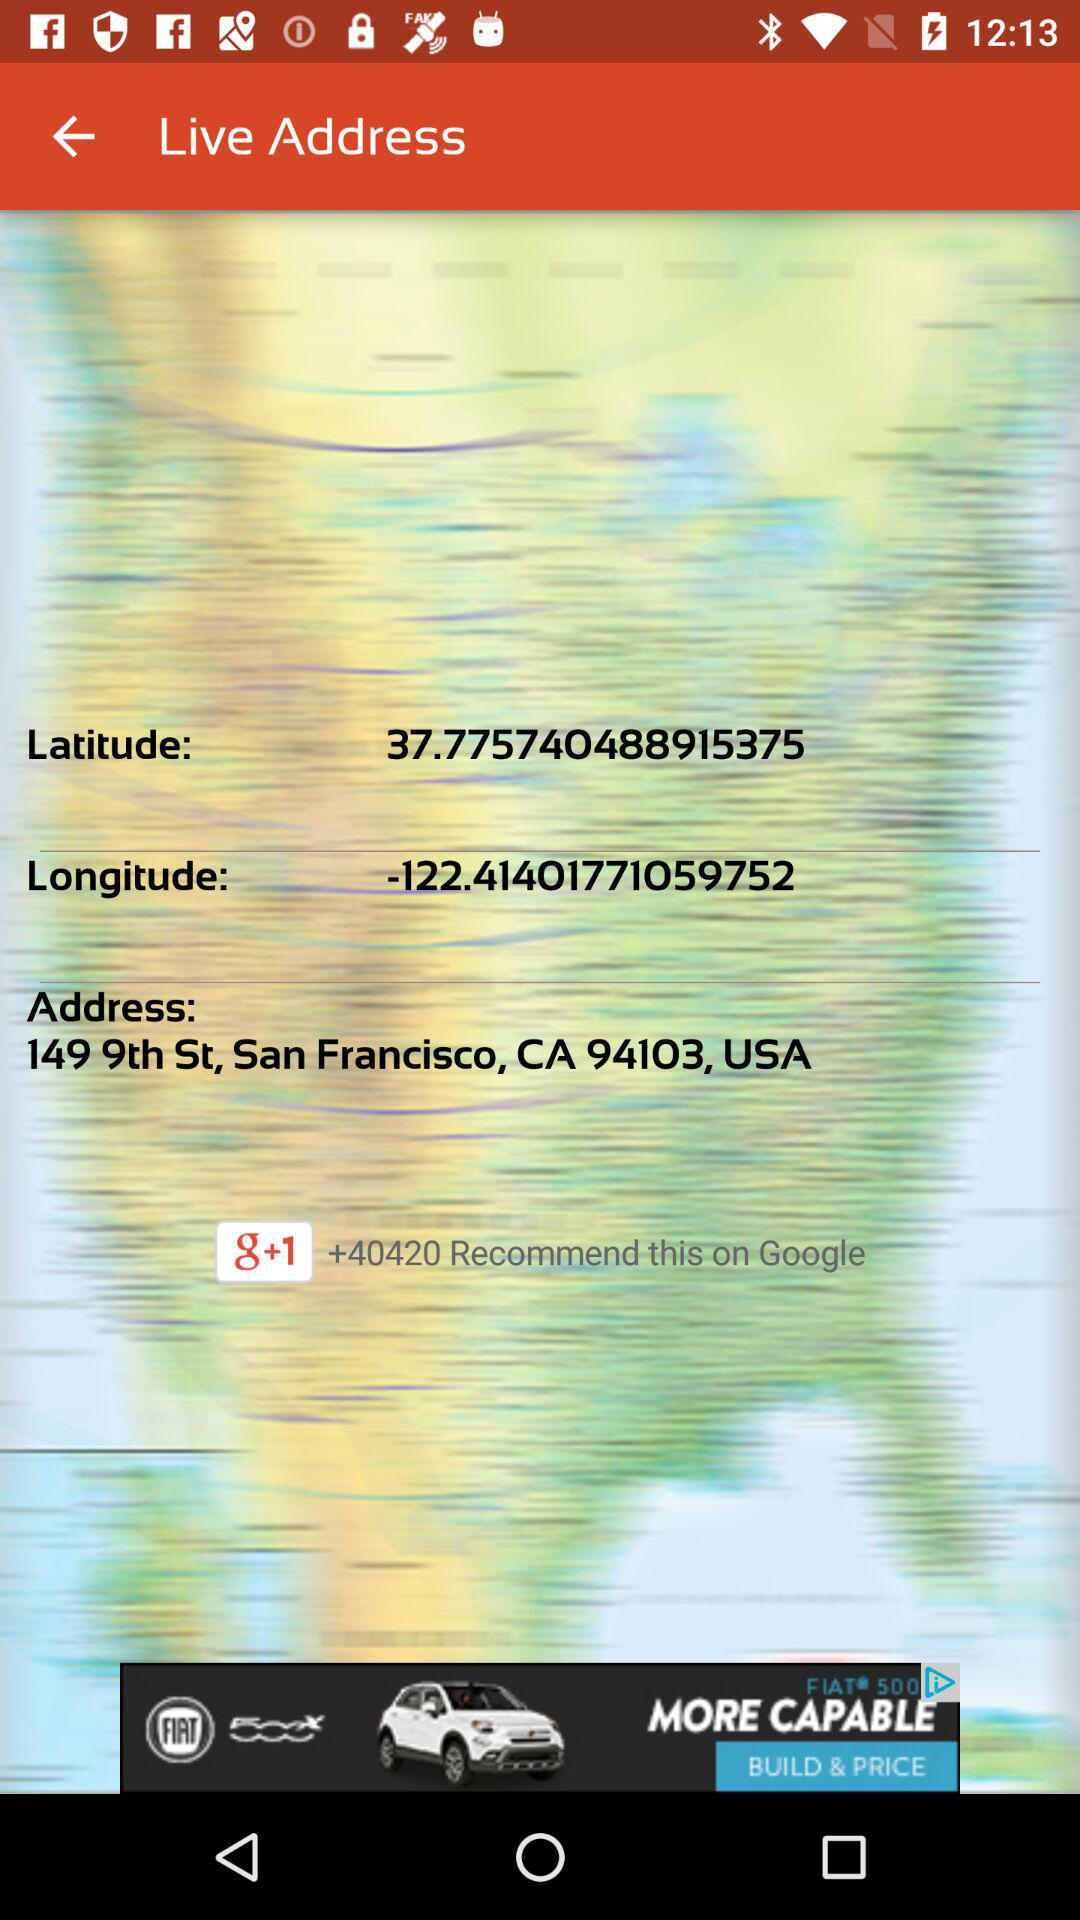What is the name of the application? The name of the application is "Live Address". 